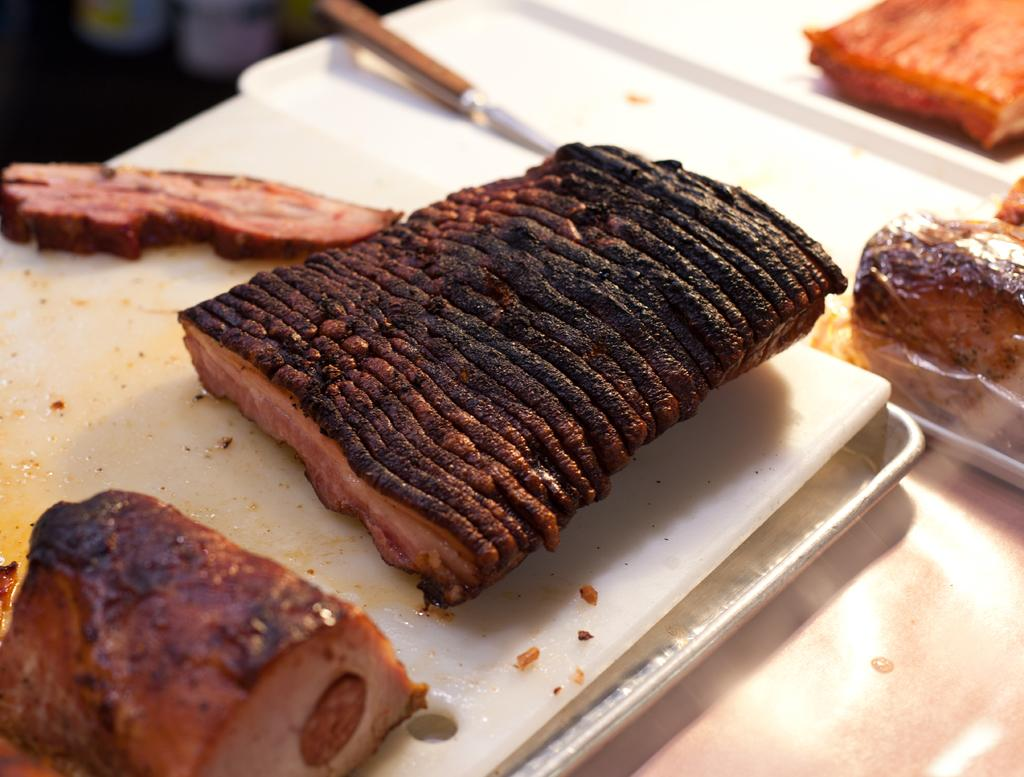What type of objects can be seen in the image? There are food items in the image. How are the food items arranged or displayed? The food items are kept on slabs, which are placed on plates. What utensil is visible in the image? There is a knife visible in the image. Can you describe the background of the image? The background of the image is blurred. What type of produce does the daughter bring to the attraction in the image? There is no daughter, produce, or attraction present in the image. 